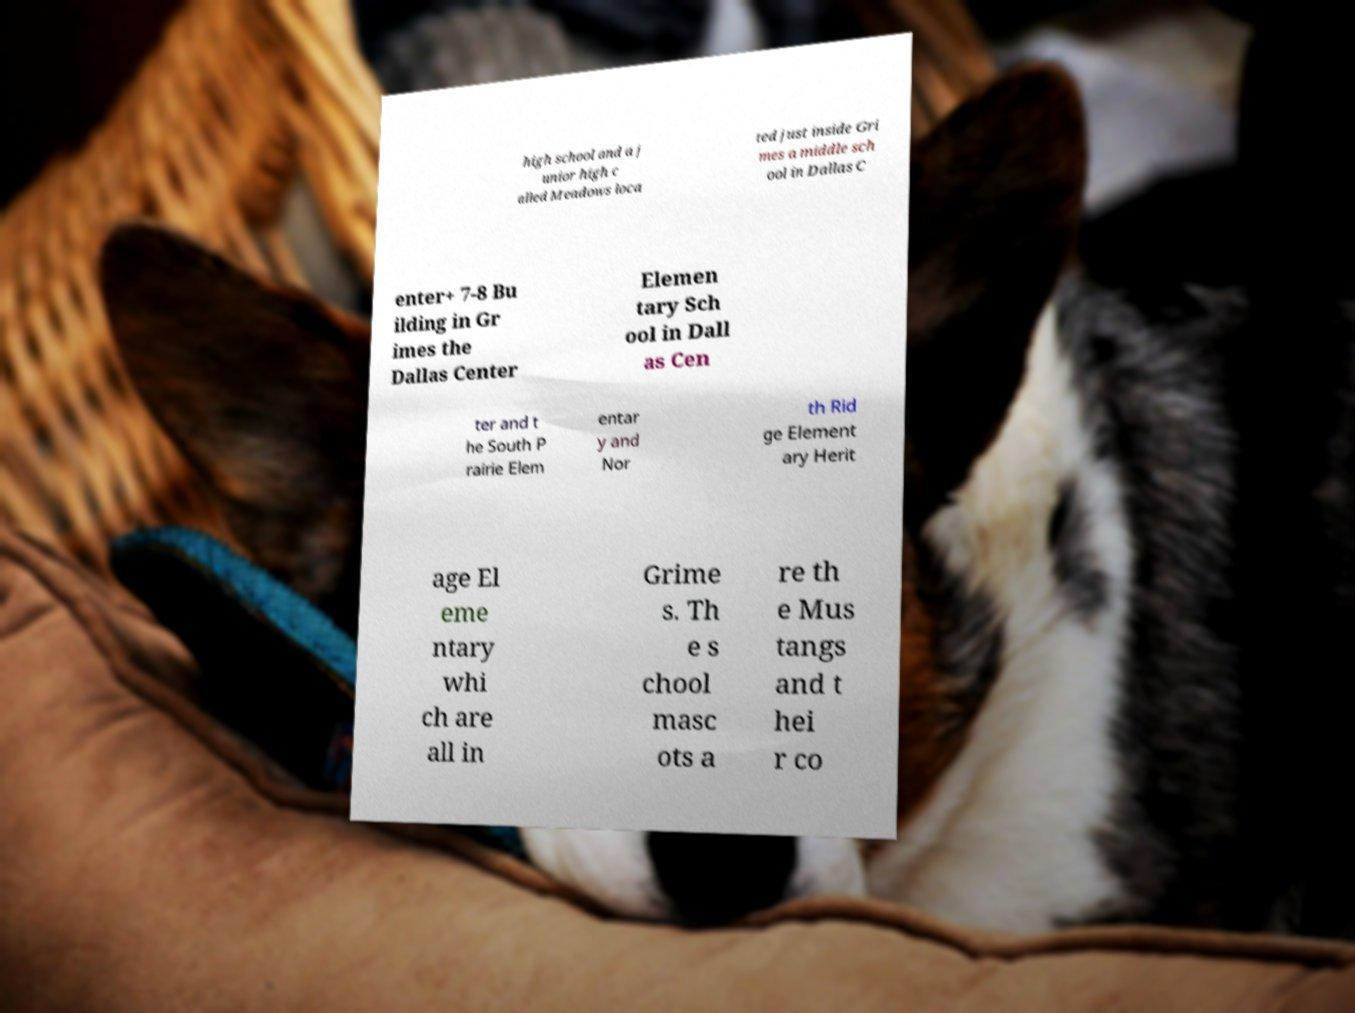Can you read and provide the text displayed in the image?This photo seems to have some interesting text. Can you extract and type it out for me? high school and a j unior high c alled Meadows loca ted just inside Gri mes a middle sch ool in Dallas C enter+ 7-8 Bu ilding in Gr imes the Dallas Center Elemen tary Sch ool in Dall as Cen ter and t he South P rairie Elem entar y and Nor th Rid ge Element ary Herit age El eme ntary whi ch are all in Grime s. Th e s chool masc ots a re th e Mus tangs and t hei r co 